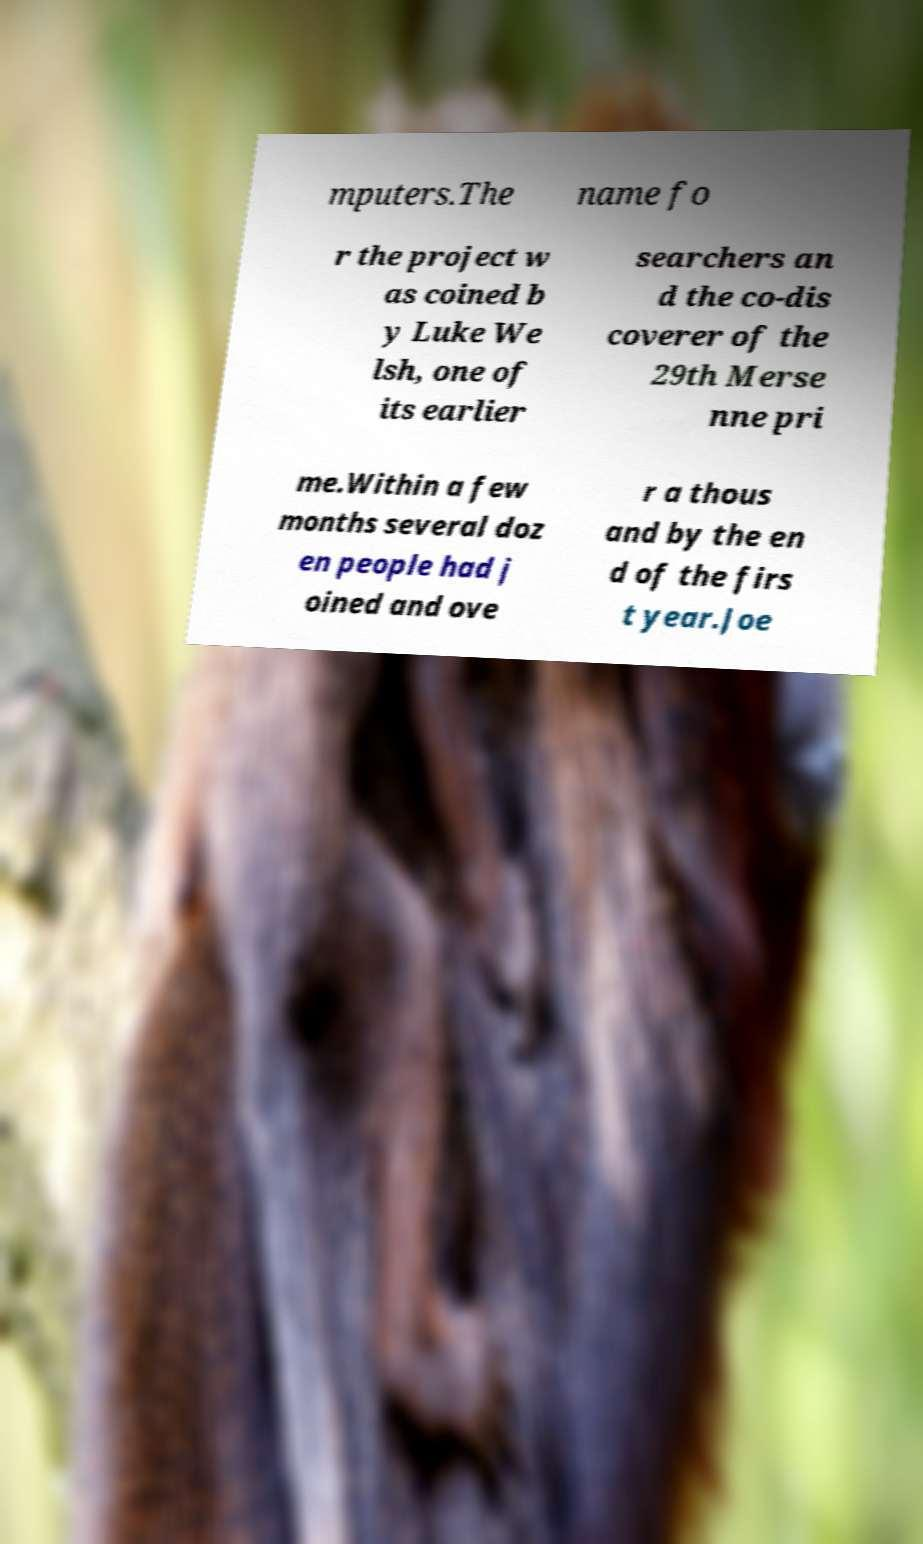Could you extract and type out the text from this image? mputers.The name fo r the project w as coined b y Luke We lsh, one of its earlier searchers an d the co-dis coverer of the 29th Merse nne pri me.Within a few months several doz en people had j oined and ove r a thous and by the en d of the firs t year.Joe 